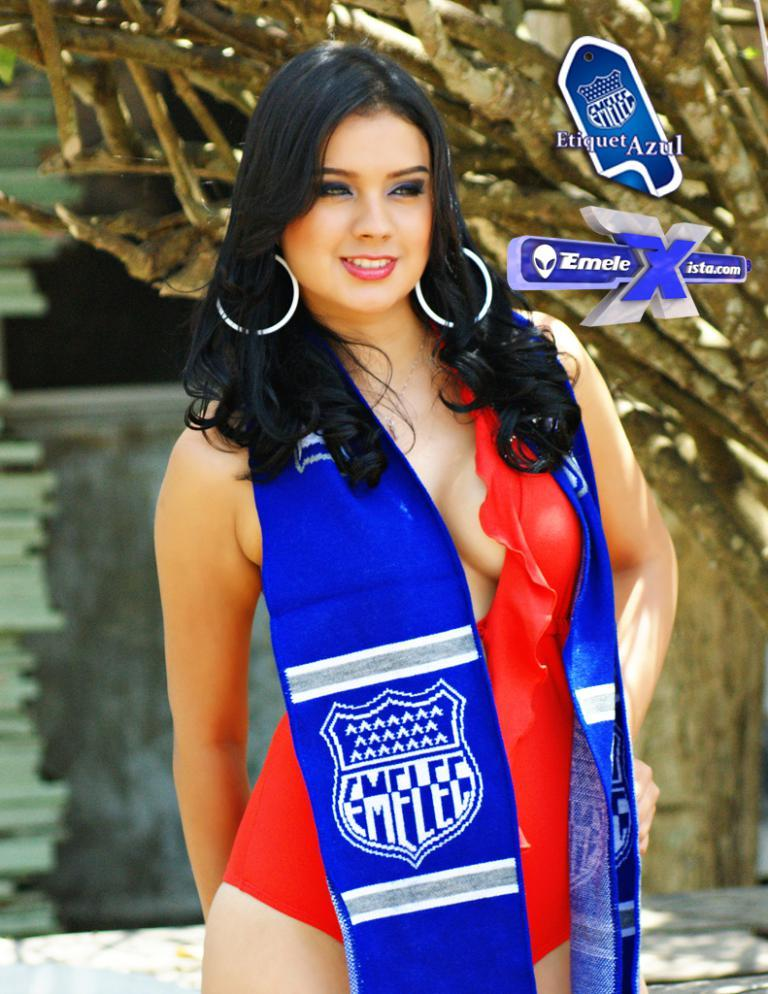What can be seen in the foreground of the image? There is a person with black hair in the foreground of the image. What is the condition of the tree in the image? There is a dry tree in the image. Where is the text located in the image? The text is in the right corner of the image. What is visible in the background of the image? There is a wall in the background of the image. How many snakes are wrapped around the person's hair in the image? There are no snakes present in the image; the person has black hair. What is the purpose of the comb in the image? There is no comb present in the image. 